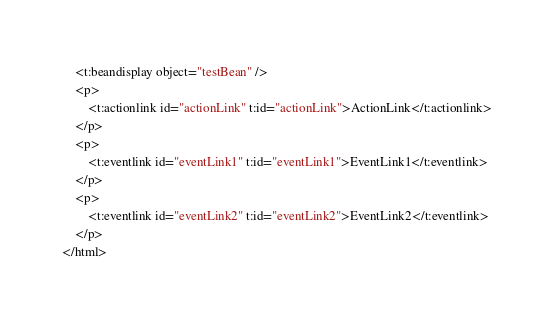<code> <loc_0><loc_0><loc_500><loc_500><_XML_>	<t:beandisplay object="testBean" />
	<p>
		<t:actionlink id="actionLink" t:id="actionLink">ActionLink</t:actionlink>
	</p>
	<p>
		<t:eventlink id="eventLink1" t:id="eventLink1">EventLink1</t:eventlink>
	</p>
	<p>
		<t:eventlink id="eventLink2" t:id="eventLink2">EventLink2</t:eventlink>
	</p>
</html>
</code> 